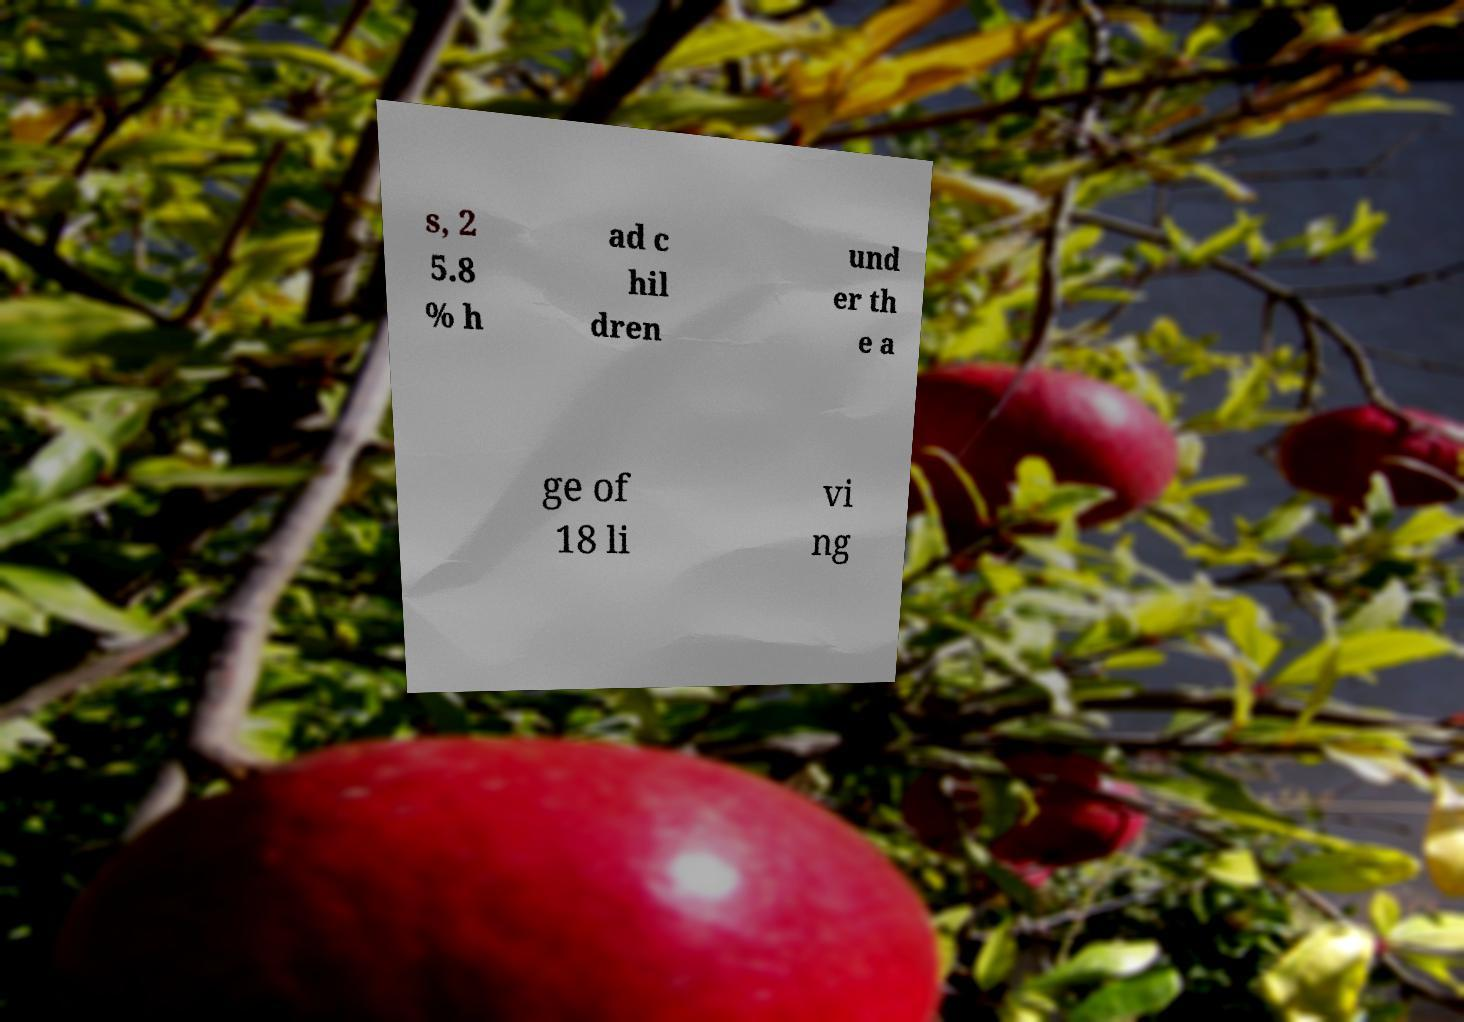Can you accurately transcribe the text from the provided image for me? s, 2 5.8 % h ad c hil dren und er th e a ge of 18 li vi ng 